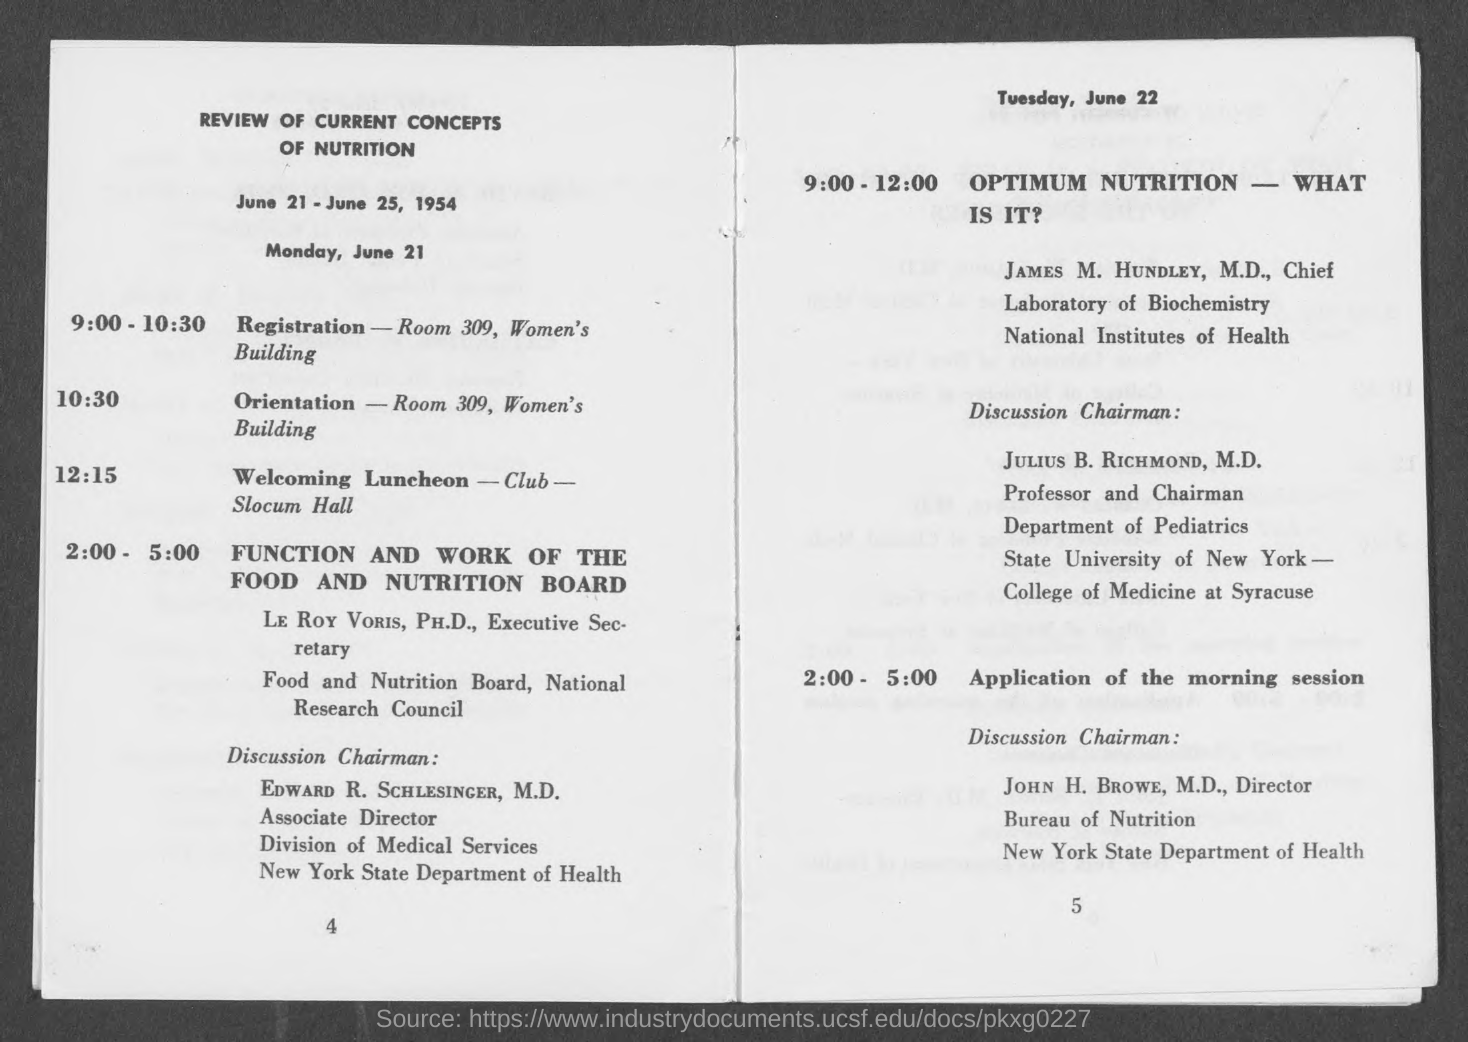Outline some significant characteristics in this image. The location of the orientation is Room 309 in the Women's Building. The registration will take place in Room 309 of the Women's Building. The document in question is titled 'A Review of Current Concepts of Nutrition.' 